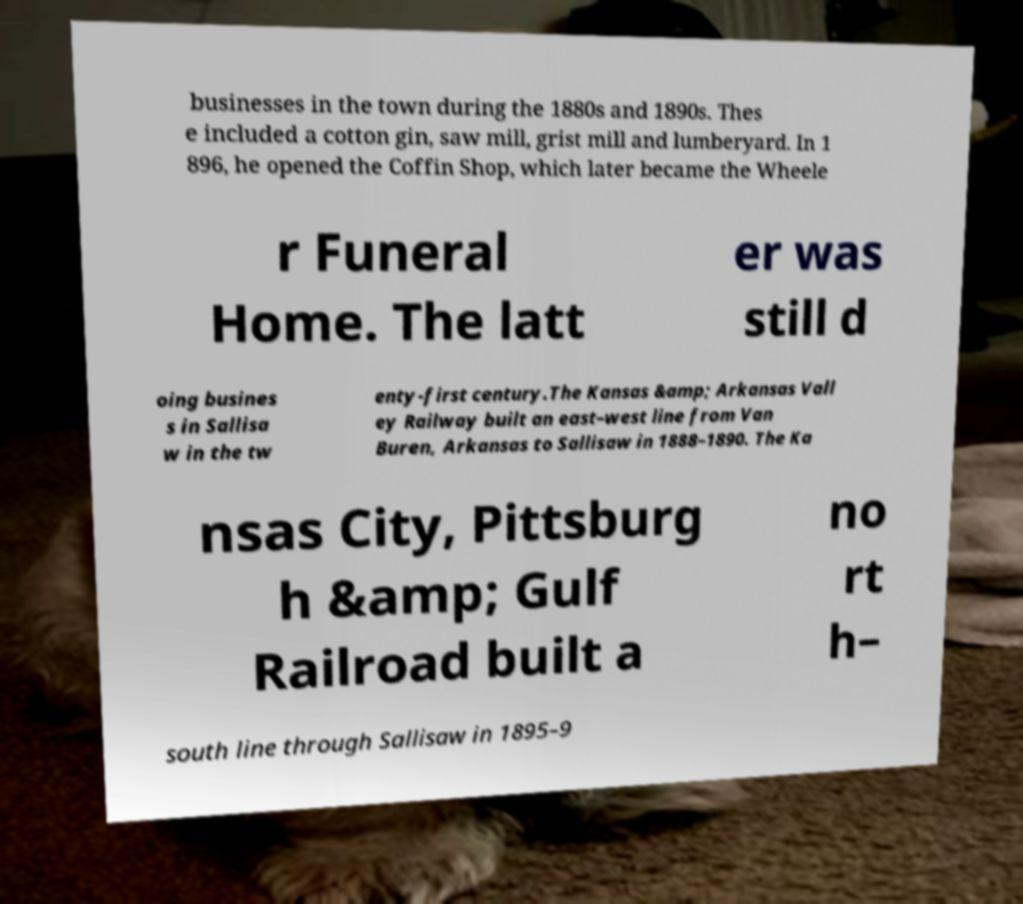Could you extract and type out the text from this image? businesses in the town during the 1880s and 1890s. Thes e included a cotton gin, saw mill, grist mill and lumberyard. In 1 896, he opened the Coffin Shop, which later became the Wheele r Funeral Home. The latt er was still d oing busines s in Sallisa w in the tw enty-first century.The Kansas &amp; Arkansas Vall ey Railway built an east–west line from Van Buren, Arkansas to Sallisaw in 1888–1890. The Ka nsas City, Pittsburg h &amp; Gulf Railroad built a no rt h– south line through Sallisaw in 1895–9 